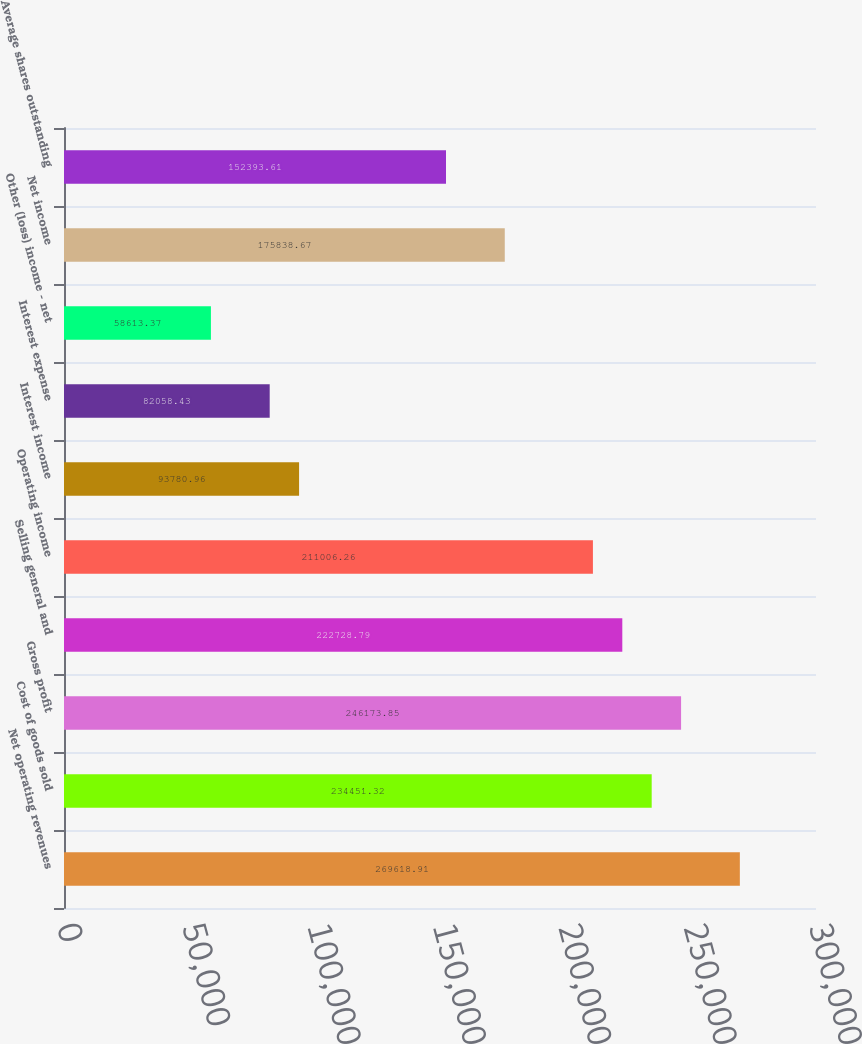Convert chart. <chart><loc_0><loc_0><loc_500><loc_500><bar_chart><fcel>Net operating revenues<fcel>Cost of goods sold<fcel>Gross profit<fcel>Selling general and<fcel>Operating income<fcel>Interest income<fcel>Interest expense<fcel>Other (loss) income - net<fcel>Net income<fcel>Average shares outstanding<nl><fcel>269619<fcel>234451<fcel>246174<fcel>222729<fcel>211006<fcel>93781<fcel>82058.4<fcel>58613.4<fcel>175839<fcel>152394<nl></chart> 